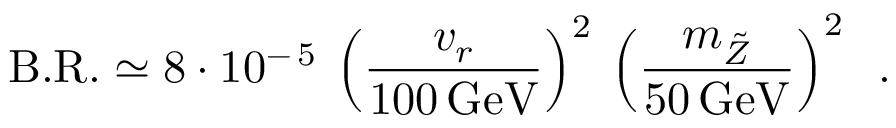Convert formula to latex. <formula><loc_0><loc_0><loc_500><loc_500>B . R . \simeq 8 \cdot 1 0 ^ { - \, 5 } \, \left ( \frac { v _ { r } } { 1 0 0 \, G e V } \right ) ^ { 2 } \, \left ( \frac { m _ { \tilde { Z } } } { 5 0 \, G e V } \right ) ^ { 2 } \, .</formula> 